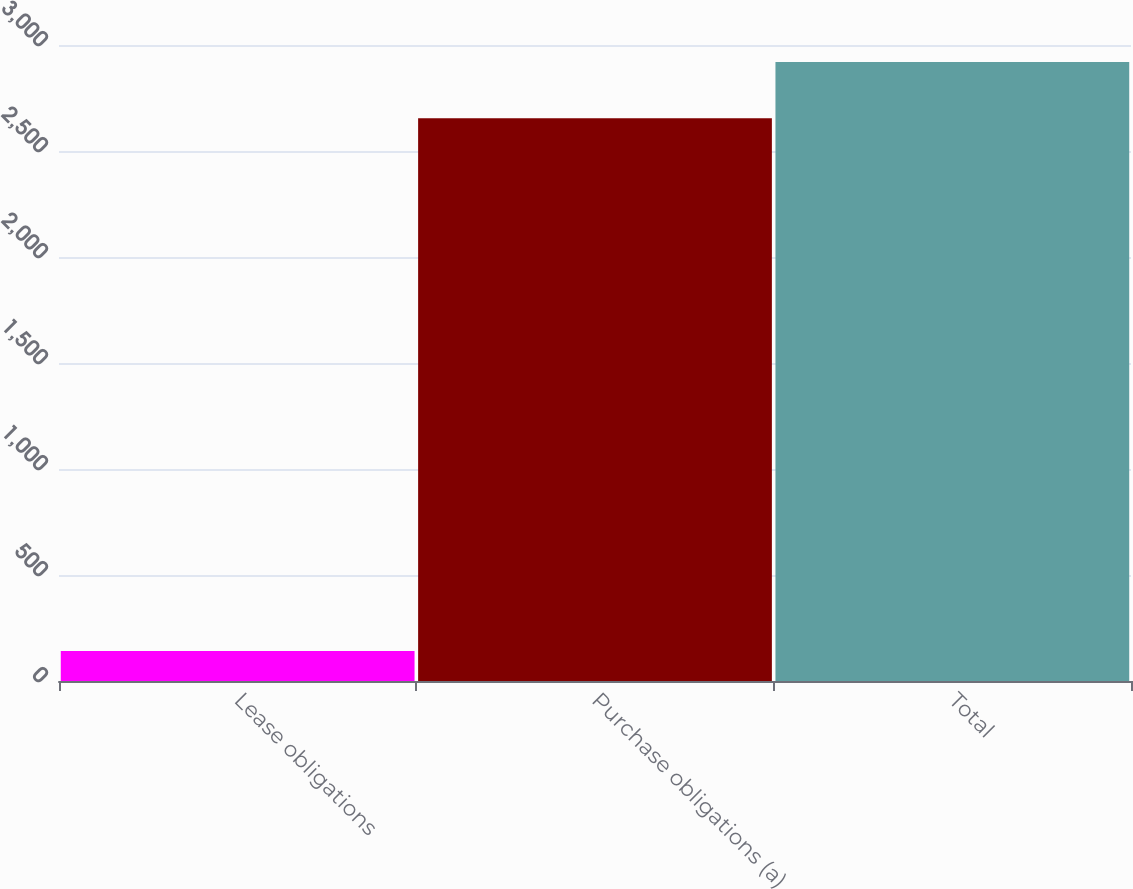<chart> <loc_0><loc_0><loc_500><loc_500><bar_chart><fcel>Lease obligations<fcel>Purchase obligations (a)<fcel>Total<nl><fcel>141<fcel>2654<fcel>2919.4<nl></chart> 